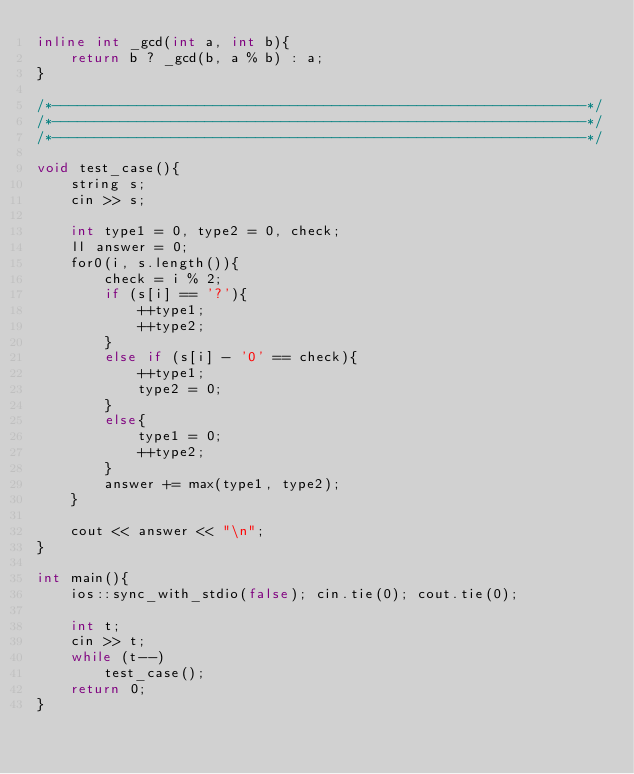<code> <loc_0><loc_0><loc_500><loc_500><_C++_>inline int _gcd(int a, int b){
    return b ? _gcd(b, a % b) : a;
}

/*---------------------------------------------------------------*/
/*---------------------------------------------------------------*/
/*---------------------------------------------------------------*/

void test_case(){
    string s;
    cin >> s;
    
    int type1 = 0, type2 = 0, check;
    ll answer = 0;
    for0(i, s.length()){
        check = i % 2;
        if (s[i] == '?'){
            ++type1;
            ++type2;
        }
        else if (s[i] - '0' == check){
            ++type1;
            type2 = 0;
        }
        else{
            type1 = 0;
            ++type2;
        }
        answer += max(type1, type2);
    }

    cout << answer << "\n";
}

int main(){
    ios::sync_with_stdio(false); cin.tie(0); cout.tie(0);
    
    int t;
    cin >> t;
    while (t--)
        test_case();
    return 0;
}
</code> 